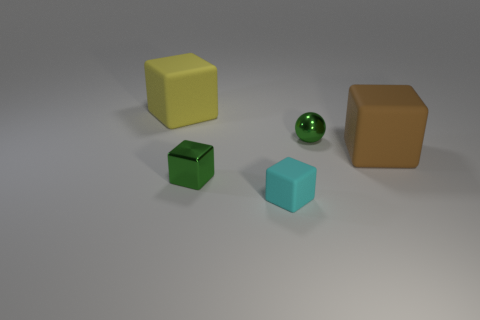Subtract all small cyan blocks. How many blocks are left? 3 Subtract 1 blocks. How many blocks are left? 3 Add 4 balls. How many objects exist? 9 Subtract all brown cubes. How many cubes are left? 3 Subtract 0 yellow cylinders. How many objects are left? 5 Subtract all blocks. How many objects are left? 1 Subtract all gray cubes. Subtract all gray cylinders. How many cubes are left? 4 Subtract all blue blocks. How many cyan balls are left? 0 Subtract all shiny objects. Subtract all red rubber balls. How many objects are left? 3 Add 5 small green blocks. How many small green blocks are left? 6 